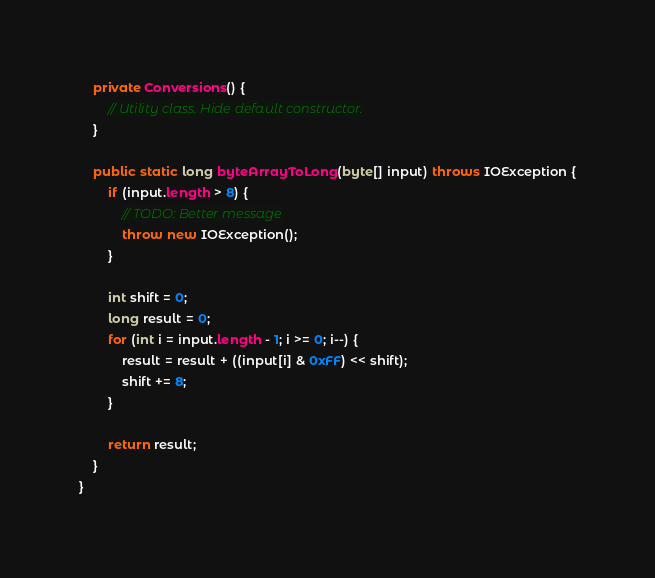<code> <loc_0><loc_0><loc_500><loc_500><_Java_>    private Conversions() {
        // Utility class. Hide default constructor.
    }

    public static long byteArrayToLong(byte[] input) throws IOException {
        if (input.length > 8) {
            // TODO: Better message
            throw new IOException();
        }

        int shift = 0;
        long result = 0;
        for (int i = input.length - 1; i >= 0; i--) {
            result = result + ((input[i] & 0xFF) << shift);
            shift += 8;
        }

        return result;
    }
}
</code> 